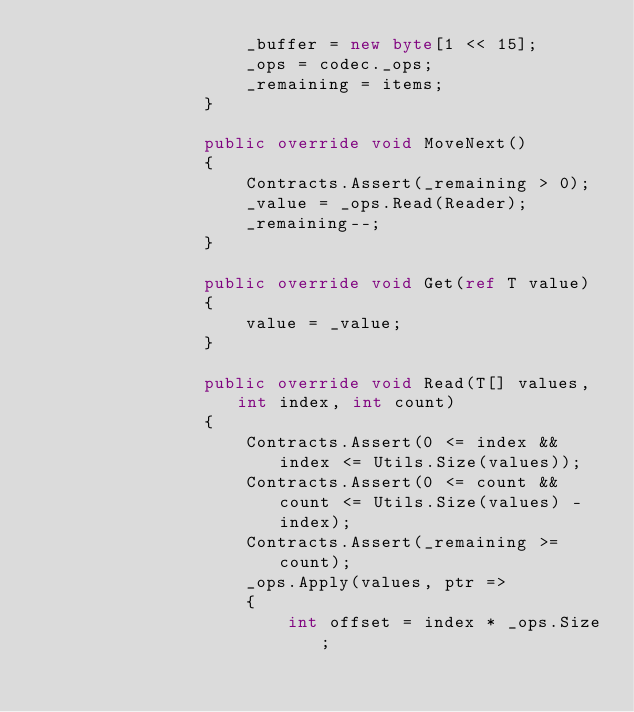Convert code to text. <code><loc_0><loc_0><loc_500><loc_500><_C#_>                    _buffer = new byte[1 << 15];
                    _ops = codec._ops;
                    _remaining = items;
                }

                public override void MoveNext()
                {
                    Contracts.Assert(_remaining > 0);
                    _value = _ops.Read(Reader);
                    _remaining--;
                }

                public override void Get(ref T value)
                {
                    value = _value;
                }

                public override void Read(T[] values, int index, int count)
                {
                    Contracts.Assert(0 <= index && index <= Utils.Size(values));
                    Contracts.Assert(0 <= count && count <= Utils.Size(values) - index);
                    Contracts.Assert(_remaining >= count);
                    _ops.Apply(values, ptr =>
                    {
                        int offset = index * _ops.Size;</code> 